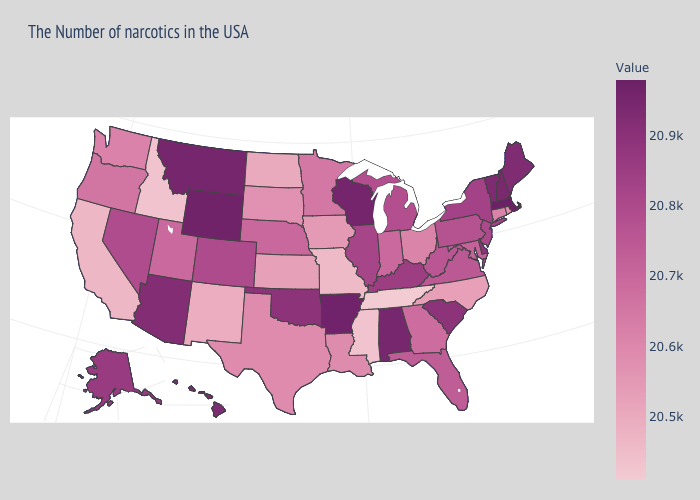Does Tennessee have the lowest value in the USA?
Write a very short answer. Yes. Does Massachusetts have the highest value in the Northeast?
Answer briefly. Yes. Does Rhode Island have the highest value in the Northeast?
Be succinct. No. 